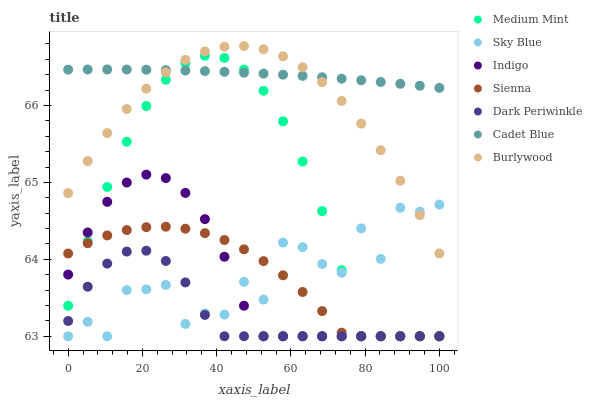Does Dark Periwinkle have the minimum area under the curve?
Answer yes or no. Yes. Does Cadet Blue have the maximum area under the curve?
Answer yes or no. Yes. Does Indigo have the minimum area under the curve?
Answer yes or no. No. Does Indigo have the maximum area under the curve?
Answer yes or no. No. Is Cadet Blue the smoothest?
Answer yes or no. Yes. Is Sky Blue the roughest?
Answer yes or no. Yes. Is Indigo the smoothest?
Answer yes or no. No. Is Indigo the roughest?
Answer yes or no. No. Does Medium Mint have the lowest value?
Answer yes or no. Yes. Does Cadet Blue have the lowest value?
Answer yes or no. No. Does Burlywood have the highest value?
Answer yes or no. Yes. Does Cadet Blue have the highest value?
Answer yes or no. No. Is Dark Periwinkle less than Burlywood?
Answer yes or no. Yes. Is Cadet Blue greater than Sienna?
Answer yes or no. Yes. Does Medium Mint intersect Sienna?
Answer yes or no. Yes. Is Medium Mint less than Sienna?
Answer yes or no. No. Is Medium Mint greater than Sienna?
Answer yes or no. No. Does Dark Periwinkle intersect Burlywood?
Answer yes or no. No. 